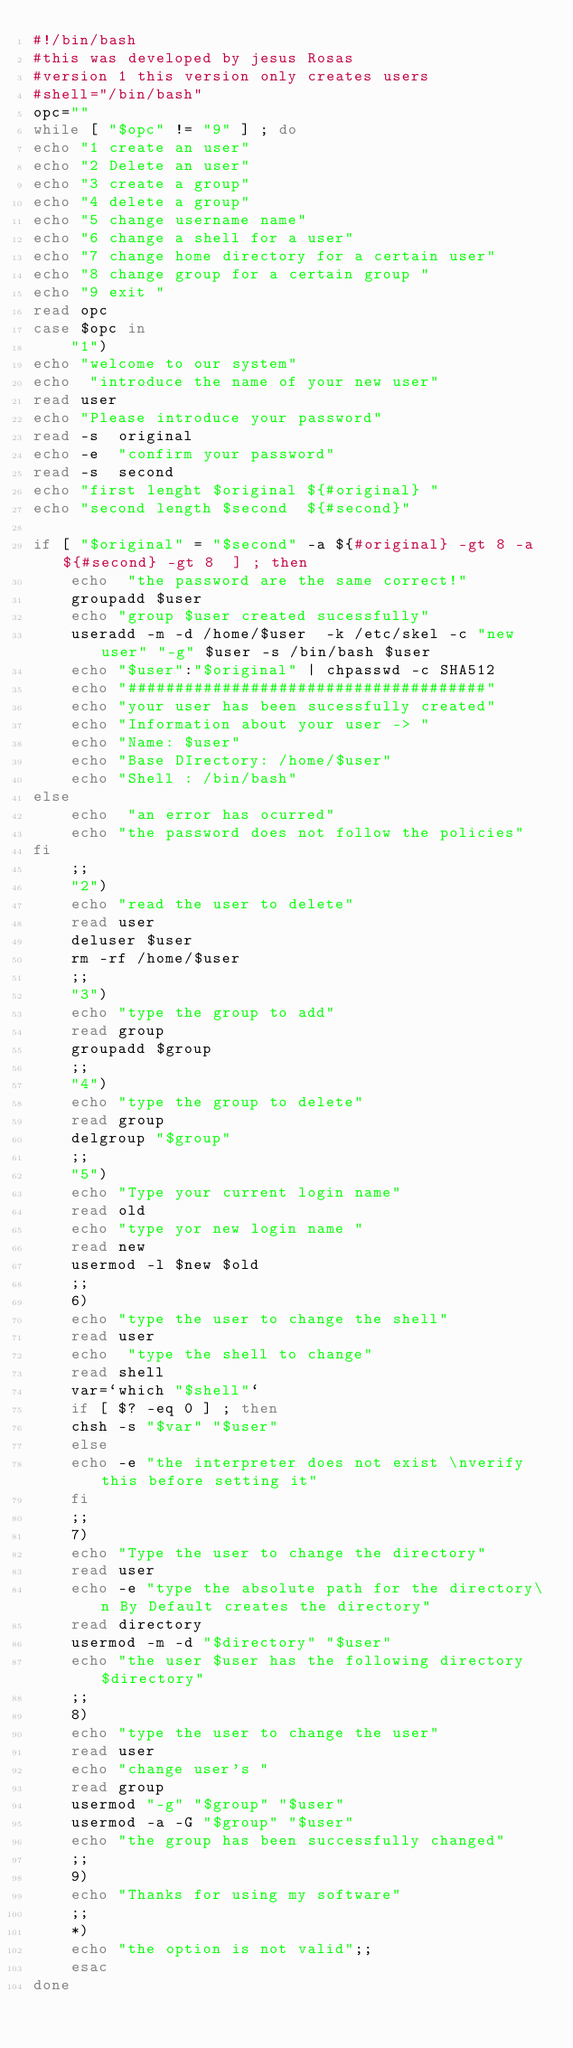<code> <loc_0><loc_0><loc_500><loc_500><_Bash_>#!/bin/bash
#this was developed by jesus Rosas
#version 1 this version only creates users
#shell="/bin/bash"
opc=""
while [ "$opc" != "9" ] ; do 
echo "1 create an user"
echo "2 Delete an user"
echo "3 create a group"
echo "4 delete a group"
echo "5 change username name"
echo "6 change a shell for a user"
echo "7 change home directory for a certain user"
echo "8 change group for a certain group "
echo "9 exit "
read opc
case $opc in
	"1")
echo "welcome to our system" 
echo  "introduce the name of your new user"
read user
echo "Please introduce your password"
read -s  original
echo -e  "confirm your password"
read -s  second
echo "first lenght $original ${#original} "
echo "second length $second  ${#second}"

if [ "$original" = "$second" -a ${#original} -gt 8 -a ${#second} -gt 8  ] ; then 
	echo  "the password are the same correct!"
	groupadd $user
	echo "group $user created sucessfully"
	useradd -m -d /home/$user  -k /etc/skel -c "new user" "-g" $user -s /bin/bash $user
	echo "$user":"$original" | chpasswd -c SHA512
	echo "######################################"
	echo "your user has been sucessfully created"
	echo "Information about your user -> "
	echo "Name: $user"
	echo "Base DIrectory: /home/$user"
	echo "Shell : /bin/bash"
else
	echo  "an error has ocurred"
	echo "the password does not follow the policies"
fi
	;;
	"2")
	echo "read the user to delete"
	read user
	deluser $user
	rm -rf /home/$user
	;;
	"3")
	echo "type the group to add"
	read group
	groupadd $group
	;;
	"4")
	echo "type the group to delete"
	read group
	delgroup "$group"
	;;
	"5")
	echo "Type your current login name"
	read old
	echo "type yor new login name "
	read new
	usermod -l $new $old
	;;
	6)
	echo "type the user to change the shell"
	read user
	echo  "type the shell to change"
	read shell
	var=`which "$shell"`
	if [ $? -eq 0 ] ; then
	chsh -s "$var" "$user"
	else
	echo -e "the interpreter does not exist \nverify this before setting it"
	fi
	;;
	7)
	echo "Type the user to change the directory"
	read user
	echo -e "type the absolute path for the directory\n By Default creates the directory"
	read directory
	usermod -m -d "$directory" "$user"
	echo "the user $user has the following directory $directory"
	;;
	8)
	echo "type the user to change the user"
	read user
	echo "change user's "
	read group
	usermod "-g" "$group" "$user"
	usermod -a -G "$group" "$user"
	echo "the group has been successfully changed"
	;;
	9)
	echo "Thanks for using my software"
	;;
	*)
	echo "the option is not valid";;
	esac
done
</code> 